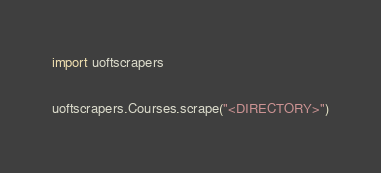Convert code to text. <code><loc_0><loc_0><loc_500><loc_500><_Python_>import uoftscrapers

uoftscrapers.Courses.scrape("<DIRECTORY>")
</code> 